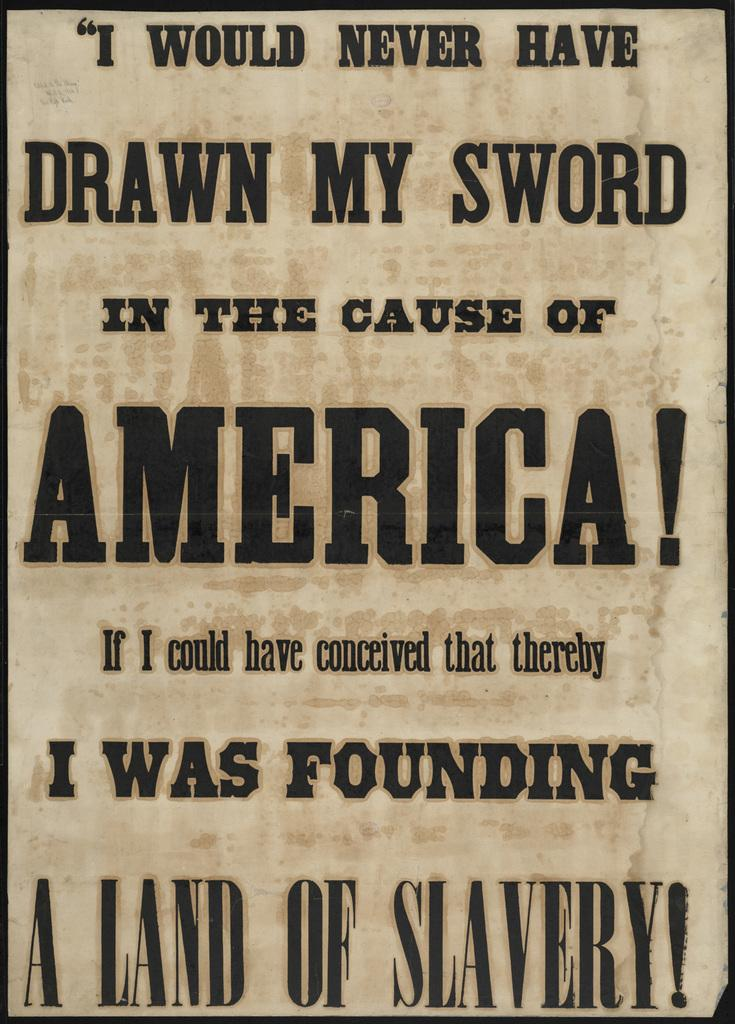<image>
Describe the image concisely. The sign does not defend America and it was created on a land of slaves. 